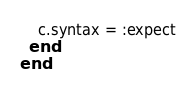Convert code to text. <code><loc_0><loc_0><loc_500><loc_500><_Ruby_>    c.syntax = :expect
  end
end
</code> 